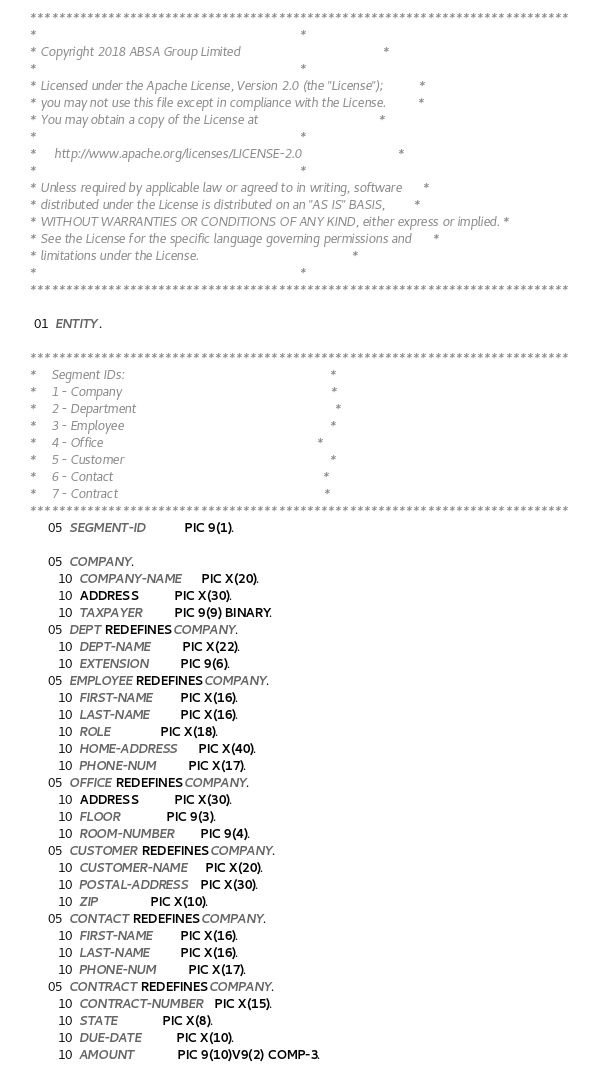<code> <loc_0><loc_0><loc_500><loc_500><_COBOL_>      ****************************************************************************
      *                                                                          *
      * Copyright 2018 ABSA Group Limited                                        *
      *                                                                          *
      * Licensed under the Apache License, Version 2.0 (the "License");          *
      * you may not use this file except in compliance with the License.         *
      * You may obtain a copy of the License at                                  *
      *                                                                          *
      *     http://www.apache.org/licenses/LICENSE-2.0                           *
      *                                                                          *
      * Unless required by applicable law or agreed to in writing, software      *
      * distributed under the License is distributed on an "AS IS" BASIS,        *
      * WITHOUT WARRANTIES OR CONDITIONS OF ANY KIND, either express or implied. *
      * See the License for the specific language governing permissions and      *
      * limitations under the License.                                           *
      *                                                                          *
      ****************************************************************************

       01  ENTITY.

      ****************************************************************************
      *    Segment IDs:                                                          *
      *    1 - Company                                                           *
      *    2 - Department                                                        *
      *    3 - Employee                                                          *
      *    4 - Office                                                            *
      *    5 - Customer                                                          *
      *    6 - Contact                                                           *
      *    7 - Contract                                                          *
      ****************************************************************************
           05  SEGMENT-ID           PIC 9(1).

           05  COMPANY.
              10  COMPANY-NAME      PIC X(20).
              10  ADDRESS           PIC X(30).
              10  TAXPAYER          PIC 9(9) BINARY.
           05  DEPT REDEFINES COMPANY.
              10  DEPT-NAME         PIC X(22).
              10  EXTENSION         PIC 9(6).
           05  EMPLOYEE REDEFINES COMPANY.
              10  FIRST-NAME        PIC X(16).
              10  LAST-NAME         PIC X(16).
              10  ROLE              PIC X(18).
              10  HOME-ADDRESS      PIC X(40).
              10  PHONE-NUM         PIC X(17).
           05  OFFICE REDEFINES COMPANY.
              10  ADDRESS           PIC X(30).
              10  FLOOR             PIC 9(3).
              10  ROOM-NUMBER       PIC 9(4).
           05  CUSTOMER REDEFINES COMPANY.
              10  CUSTOMER-NAME     PIC X(20).
              10  POSTAL-ADDRESS    PIC X(30).
              10  ZIP               PIC X(10).
           05  CONTACT REDEFINES COMPANY.
              10  FIRST-NAME        PIC X(16).
              10  LAST-NAME         PIC X(16).
              10  PHONE-NUM         PIC X(17).
           05  CONTRACT REDEFINES COMPANY.
              10  CONTRACT-NUMBER   PIC X(15).
              10  STATE             PIC X(8).
              10  DUE-DATE          PIC X(10).
              10  AMOUNT            PIC 9(10)V9(2) COMP-3.
</code> 